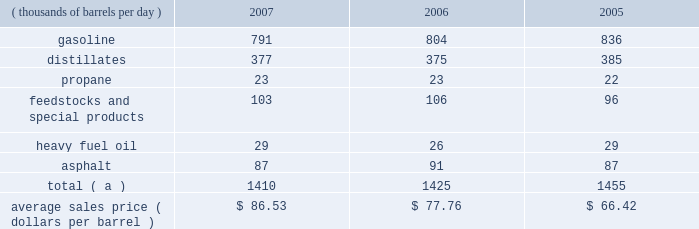Marketing we are a supplier of gasoline and distillates to resellers and consumers within our market area in the midwest , upper great plains , gulf coast and southeastern regions of the united states .
In 2007 , our refined products sales volumes totaled 21.6 billion gallons , or 1.410 mmbpd .
The average sales price of our refined products in aggregate was $ 86.53 per barrel for 2007 .
The table sets forth our refined products sales by product group and our average sales price for each of the last three years .
Refined product sales ( thousands of barrels per day ) 2007 2006 2005 .
Total ( a ) 1410 1425 1455 average sales price ( dollars per barrel ) $ 86.53 $ 77.76 $ 66.42 ( a ) includes matching buy/sell volumes of 24 mbpd and 77 mbpd in 2006 and 2005 .
On april 1 , 2006 , we changed our accounting for matching buy/sell arrangements as a result of a new accounting standard .
This change resulted in lower refined products sales volumes for 2007 and the remainder of 2006 than would have been reported under our previous accounting practices .
See note 2 to the consolidated financial statements .
The wholesale distribution of petroleum products to private brand marketers and to large commercial and industrial consumers and sales in the spot market accounted for 69 percent of our refined products sales volumes in 2007 .
We sold 49 percent of our gasoline volumes and 89 percent of our distillates volumes on a wholesale or spot market basis .
Half of our propane is sold into the home heating market , with the balance being purchased by industrial consumers .
Propylene , cumene , aromatics , aliphatics and sulfur are domestically marketed to customers in the chemical industry .
Base lube oils , maleic anhydride , slack wax , extract and pitch are sold throughout the united states and canada , with pitch products also being exported worldwide .
We market asphalt through owned and leased terminals throughout the midwest , upper great plains , gulf coast and southeastern regions of the united states .
Our customer base includes approximately 750 asphalt-paving contractors , government entities ( states , counties , cities and townships ) and asphalt roofing shingle manufacturers .
We have blended ethanol with gasoline for over 15 years and increased our blending program in 2007 , in part due to renewable fuel mandates .
We blended 41 mbpd of ethanol into gasoline in 2007 and 35 mbpd in both 2006 and 2005 .
The future expansion or contraction of our ethanol blending program will be driven by the economics of the ethanol supply and changes in government regulations .
We sell reformulated gasoline in parts of our marketing territory , primarily chicago , illinois ; louisville , kentucky ; northern kentucky ; milwaukee , wisconsin and hartford , illinois , and we sell low-vapor-pressure gasoline in nine states .
We also sell biodiesel in minnesota , illinois and kentucky .
As of december 31 , 2007 , we supplied petroleum products to about 4400 marathon branded-retail outlets located primarily in ohio , michigan , indiana , kentucky and illinois .
Branded retail outlets are also located in georgia , florida , minnesota , wisconsin , north carolina , tennessee , west virginia , virginia , south carolina , alabama , pennsylvania , and texas .
Sales to marathon-brand jobbers and dealers accounted for 16 percent of our refined product sales volumes in 2007 .
Speedway superamerica llc ( 201cssa 201d ) , our wholly-owned subsidiary , sells gasoline and diesel fuel primarily through retail outlets that we operate .
Sales of refined products through these ssa retail outlets accounted for 15 percent of our refined products sales volumes in 2007 .
As of december 31 , 2007 , ssa had 1636 retail outlets in nine states that sold petroleum products and convenience store merchandise and services , primarily under the brand names 201cspeedway 201d and 201csuperamerica . 201d ssa 2019s revenues from the sale of non-petroleum merchandise totaled $ 2.796 billion in 2007 , compared with $ 2.706 billion in 2006 .
Profit levels from the sale of such merchandise and services tend to be less volatile than profit levels from the retail sale of gasoline and diesel fuel .
Ssa also operates 59 valvoline instant oil change retail outlets located in michigan and northwest ohio .
Pilot travel centers llc ( 201cptc 201d ) , our joint venture with pilot corporation ( 201cpilot 201d ) , is the largest operator of travel centers in the united states with 286 locations in 37 states and canada at december 31 , 2007 .
The travel centers offer diesel fuel , gasoline and a variety of other services , including on-premises brand-name restaurants at many locations .
Pilot and marathon each own a 50 percent interest in ptc. .
Based on the average sales price listed above , what was the refined product sales total for 2007? 
Computations: (1410 * 86.53)
Answer: 122007.3. 